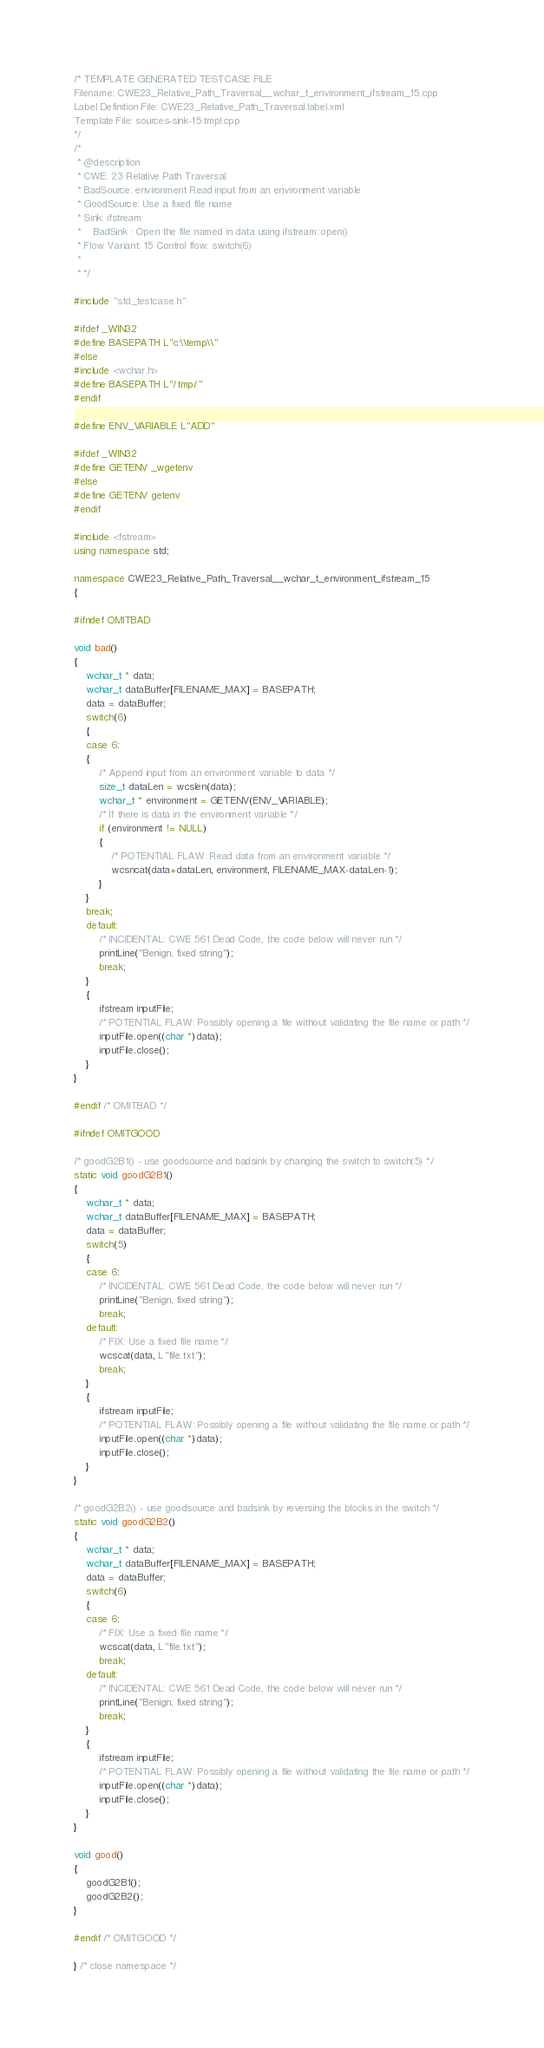Convert code to text. <code><loc_0><loc_0><loc_500><loc_500><_C++_>/* TEMPLATE GENERATED TESTCASE FILE
Filename: CWE23_Relative_Path_Traversal__wchar_t_environment_ifstream_15.cpp
Label Definition File: CWE23_Relative_Path_Traversal.label.xml
Template File: sources-sink-15.tmpl.cpp
*/
/*
 * @description
 * CWE: 23 Relative Path Traversal
 * BadSource: environment Read input from an environment variable
 * GoodSource: Use a fixed file name
 * Sink: ifstream
 *    BadSink : Open the file named in data using ifstream::open()
 * Flow Variant: 15 Control flow: switch(6)
 *
 * */

#include "std_testcase.h"

#ifdef _WIN32
#define BASEPATH L"c:\\temp\\"
#else
#include <wchar.h>
#define BASEPATH L"/tmp/"
#endif

#define ENV_VARIABLE L"ADD"

#ifdef _WIN32
#define GETENV _wgetenv
#else
#define GETENV getenv
#endif

#include <fstream>
using namespace std;

namespace CWE23_Relative_Path_Traversal__wchar_t_environment_ifstream_15
{

#ifndef OMITBAD

void bad()
{
    wchar_t * data;
    wchar_t dataBuffer[FILENAME_MAX] = BASEPATH;
    data = dataBuffer;
    switch(6)
    {
    case 6:
    {
        /* Append input from an environment variable to data */
        size_t dataLen = wcslen(data);
        wchar_t * environment = GETENV(ENV_VARIABLE);
        /* If there is data in the environment variable */
        if (environment != NULL)
        {
            /* POTENTIAL FLAW: Read data from an environment variable */
            wcsncat(data+dataLen, environment, FILENAME_MAX-dataLen-1);
        }
    }
    break;
    default:
        /* INCIDENTAL: CWE 561 Dead Code, the code below will never run */
        printLine("Benign, fixed string");
        break;
    }
    {
        ifstream inputFile;
        /* POTENTIAL FLAW: Possibly opening a file without validating the file name or path */
        inputFile.open((char *)data);
        inputFile.close();
    }
}

#endif /* OMITBAD */

#ifndef OMITGOOD

/* goodG2B1() - use goodsource and badsink by changing the switch to switch(5) */
static void goodG2B1()
{
    wchar_t * data;
    wchar_t dataBuffer[FILENAME_MAX] = BASEPATH;
    data = dataBuffer;
    switch(5)
    {
    case 6:
        /* INCIDENTAL: CWE 561 Dead Code, the code below will never run */
        printLine("Benign, fixed string");
        break;
    default:
        /* FIX: Use a fixed file name */
        wcscat(data, L"file.txt");
        break;
    }
    {
        ifstream inputFile;
        /* POTENTIAL FLAW: Possibly opening a file without validating the file name or path */
        inputFile.open((char *)data);
        inputFile.close();
    }
}

/* goodG2B2() - use goodsource and badsink by reversing the blocks in the switch */
static void goodG2B2()
{
    wchar_t * data;
    wchar_t dataBuffer[FILENAME_MAX] = BASEPATH;
    data = dataBuffer;
    switch(6)
    {
    case 6:
        /* FIX: Use a fixed file name */
        wcscat(data, L"file.txt");
        break;
    default:
        /* INCIDENTAL: CWE 561 Dead Code, the code below will never run */
        printLine("Benign, fixed string");
        break;
    }
    {
        ifstream inputFile;
        /* POTENTIAL FLAW: Possibly opening a file without validating the file name or path */
        inputFile.open((char *)data);
        inputFile.close();
    }
}

void good()
{
    goodG2B1();
    goodG2B2();
}

#endif /* OMITGOOD */

} /* close namespace */
</code> 